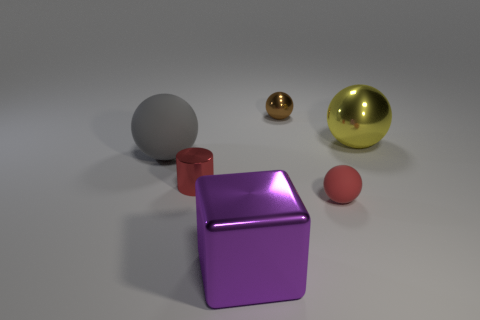What size is the ball that is the same color as the metallic cylinder?
Make the answer very short. Small. What shape is the metal thing that is in front of the small red metal thing?
Your answer should be very brief. Cube. There is a small shiny thing in front of the yellow sphere; are there any red metallic objects that are to the left of it?
Your answer should be very brief. No. There is a object that is both behind the big purple cube and in front of the metal cylinder; what color is it?
Make the answer very short. Red. There is a small red object on the right side of the tiny object that is left of the block; are there any yellow metallic balls in front of it?
Offer a very short reply. No. There is a red thing that is the same shape as the gray object; what is its size?
Provide a succinct answer. Small. Is there any other thing that has the same material as the small red cylinder?
Ensure brevity in your answer.  Yes. Are there any large yellow things?
Make the answer very short. Yes. There is a tiny matte ball; is its color the same as the tiny metal object in front of the yellow ball?
Keep it short and to the point. Yes. What size is the rubber object in front of the large ball that is to the left of the red thing that is in front of the small shiny cylinder?
Ensure brevity in your answer.  Small. 